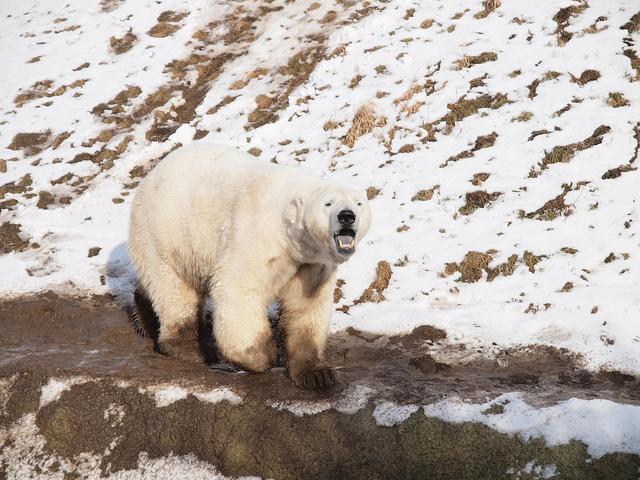Is the bear sleeping?
Quick response, please. No. What color is the animal in the background?
Be succinct. White. Where is the Polar bear at?
Give a very brief answer. Zoo. What type of bear is this?
Be succinct. Polar. Is the bear clean?
Keep it brief. No. How many animals are pictured here?
Be succinct. 1. Is the polar bear's mouth closed?
Write a very short answer. No. Is the bear trying to find food?
Give a very brief answer. Yes. Is this animal roaming around?
Be succinct. Yes. Is the animal in the photo sleeping?
Give a very brief answer. No. Is the polar bear in an enclosure?
Concise answer only. No. What is just above the bear's head?
Quick response, please. Snow. Which animals are these?
Short answer required. Polar bear. Is he in his natural environment?
Quick response, please. Yes. What kind of animal is depicted in the scene?
Keep it brief. Polar bear. What color is the bear?
Give a very brief answer. White. What is the bear doing?
Give a very brief answer. Walking. 